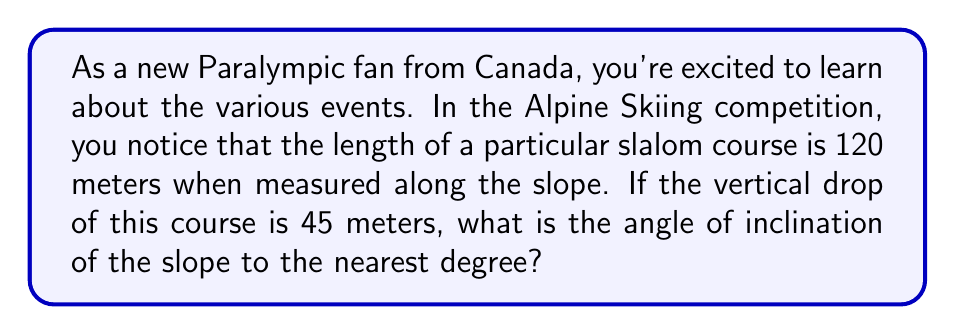Provide a solution to this math problem. Let's approach this step-by-step:

1) We can visualize this as a right triangle, where:
   - The hypotenuse is the length of the slope (120 m)
   - The opposite side is the vertical drop (45 m)
   - The angle we're looking for is the one between the slope and the horizontal

2) To find the angle, we can use the sine function:

   $\sin(\theta) = \frac{\text{opposite}}{\text{hypotenuse}}$

3) Substituting our known values:

   $\sin(\theta) = \frac{45}{120}$

4) To solve for $\theta$, we need to take the inverse sine (arcsin) of both sides:

   $\theta = \arcsin(\frac{45}{120})$

5) Using a calculator (or computer):

   $\theta \approx 22.0233...$

6) Rounding to the nearest degree:

   $\theta \approx 22°$

[asy]
import geometry;

size(200);
pair A=(0,0), B=(100,0), C=(0,40);
draw(A--B--C--A);
draw(rightanglemark(A,B,C,20));
label("120 m",B--C,E);
label("45 m",A--C,W);
label("$\theta$",A,SE);
[/asy]

This diagram illustrates the slope, with the angle $\theta$ that we calculated.
Answer: The angle of inclination of the Paralympic ski slope is approximately 22°. 